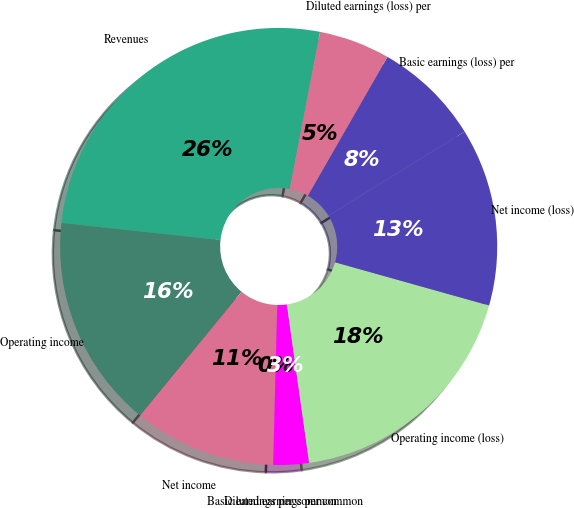Convert chart. <chart><loc_0><loc_0><loc_500><loc_500><pie_chart><fcel>Revenues<fcel>Operating income<fcel>Net income<fcel>Basic earnings per common<fcel>Diluted earnings per common<fcel>Operating income (loss)<fcel>Net income (loss)<fcel>Basic earnings (loss) per<fcel>Diluted earnings (loss) per<nl><fcel>26.31%<fcel>15.79%<fcel>10.53%<fcel>0.0%<fcel>2.63%<fcel>18.42%<fcel>13.16%<fcel>7.9%<fcel>5.26%<nl></chart> 